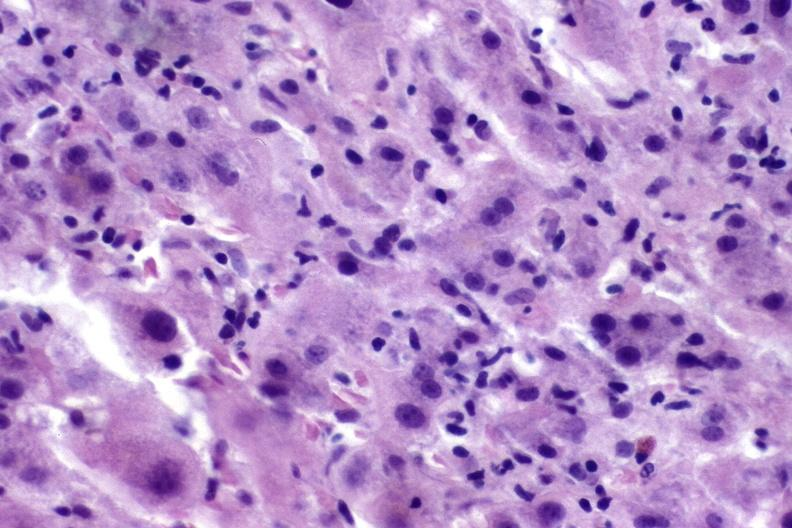does this myoma show autoimmune hepatitis?
Answer the question using a single word or phrase. No 